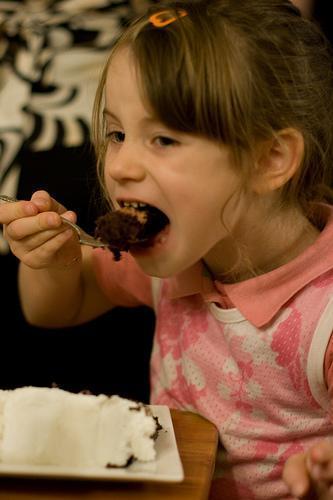How many children are there?
Give a very brief answer. 1. 